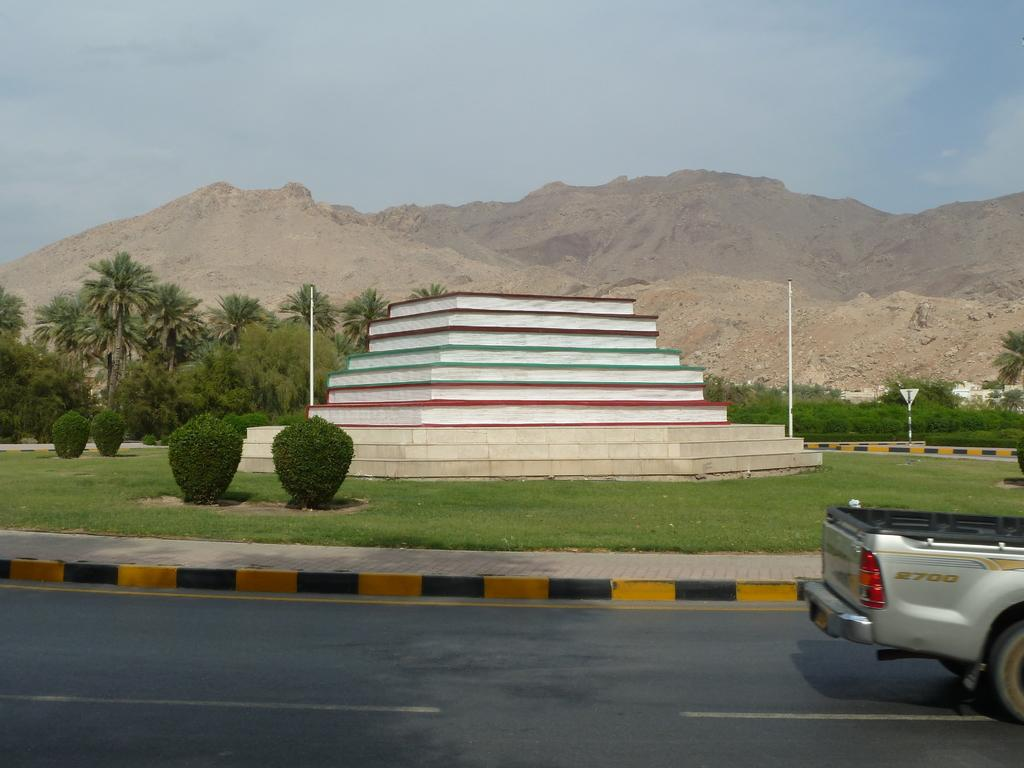<image>
Render a clear and concise summary of the photo. The tail end of a pickup that says 2700 on it in front of a pyramidal type statue. 